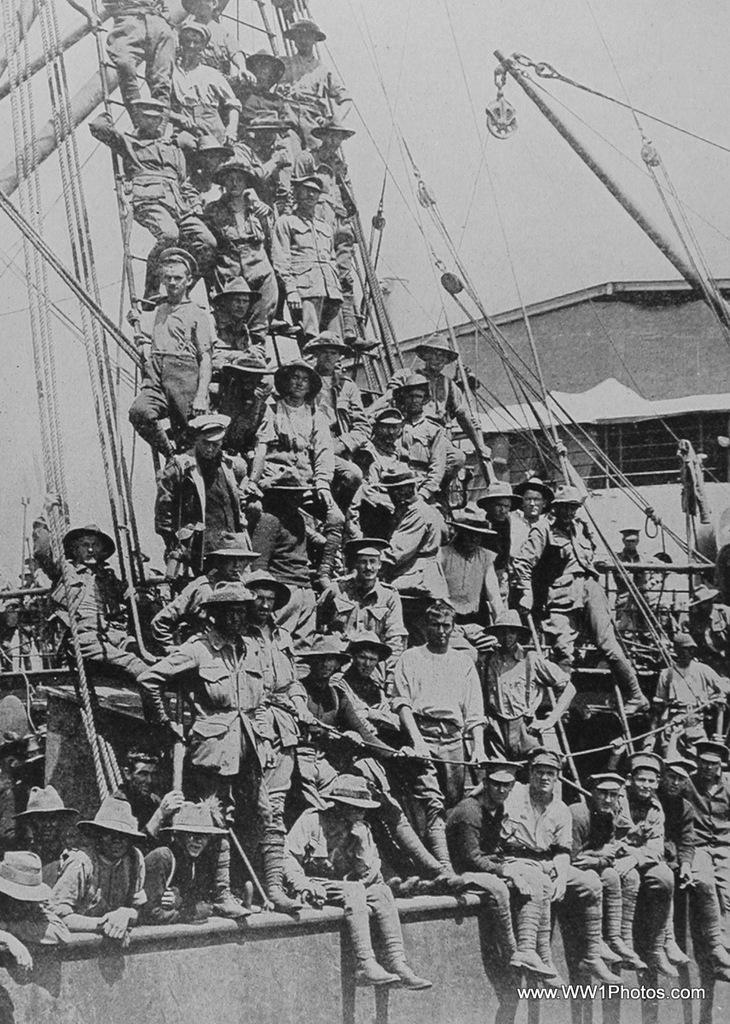How would you summarize this image in a sentence or two? In this image there a few people on the ship, there is a building, few poles and ropes. 